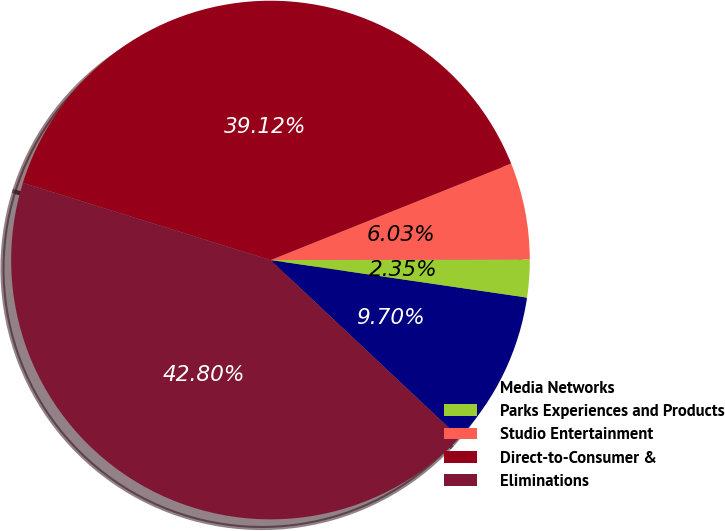<chart> <loc_0><loc_0><loc_500><loc_500><pie_chart><fcel>Media Networks<fcel>Parks Experiences and Products<fcel>Studio Entertainment<fcel>Direct-to-Consumer &<fcel>Eliminations<nl><fcel>9.7%<fcel>2.35%<fcel>6.03%<fcel>39.12%<fcel>42.8%<nl></chart> 